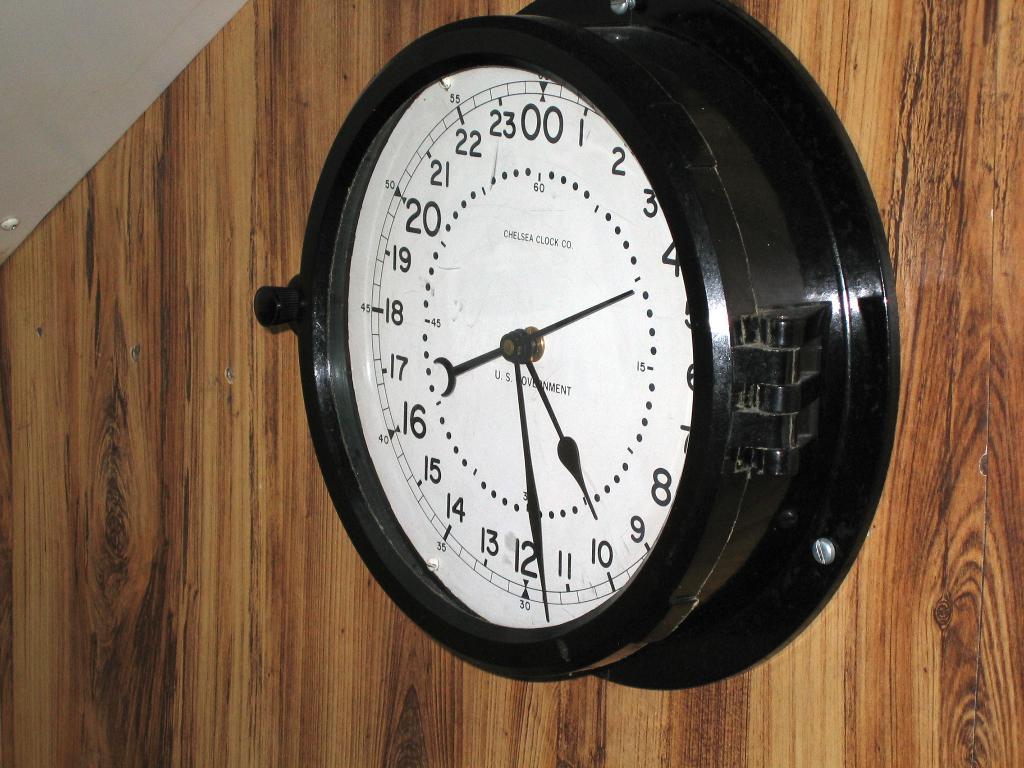What number is the seconds hand pointing to?
Make the answer very short. 4. What number is in the 12-o'clock potion of this clock?
Provide a short and direct response. 00. 